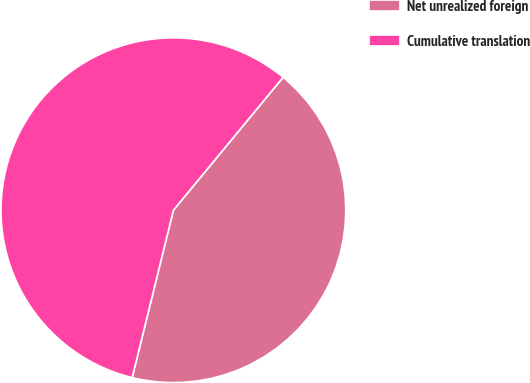Convert chart. <chart><loc_0><loc_0><loc_500><loc_500><pie_chart><fcel>Net unrealized foreign<fcel>Cumulative translation<nl><fcel>42.86%<fcel>57.14%<nl></chart> 